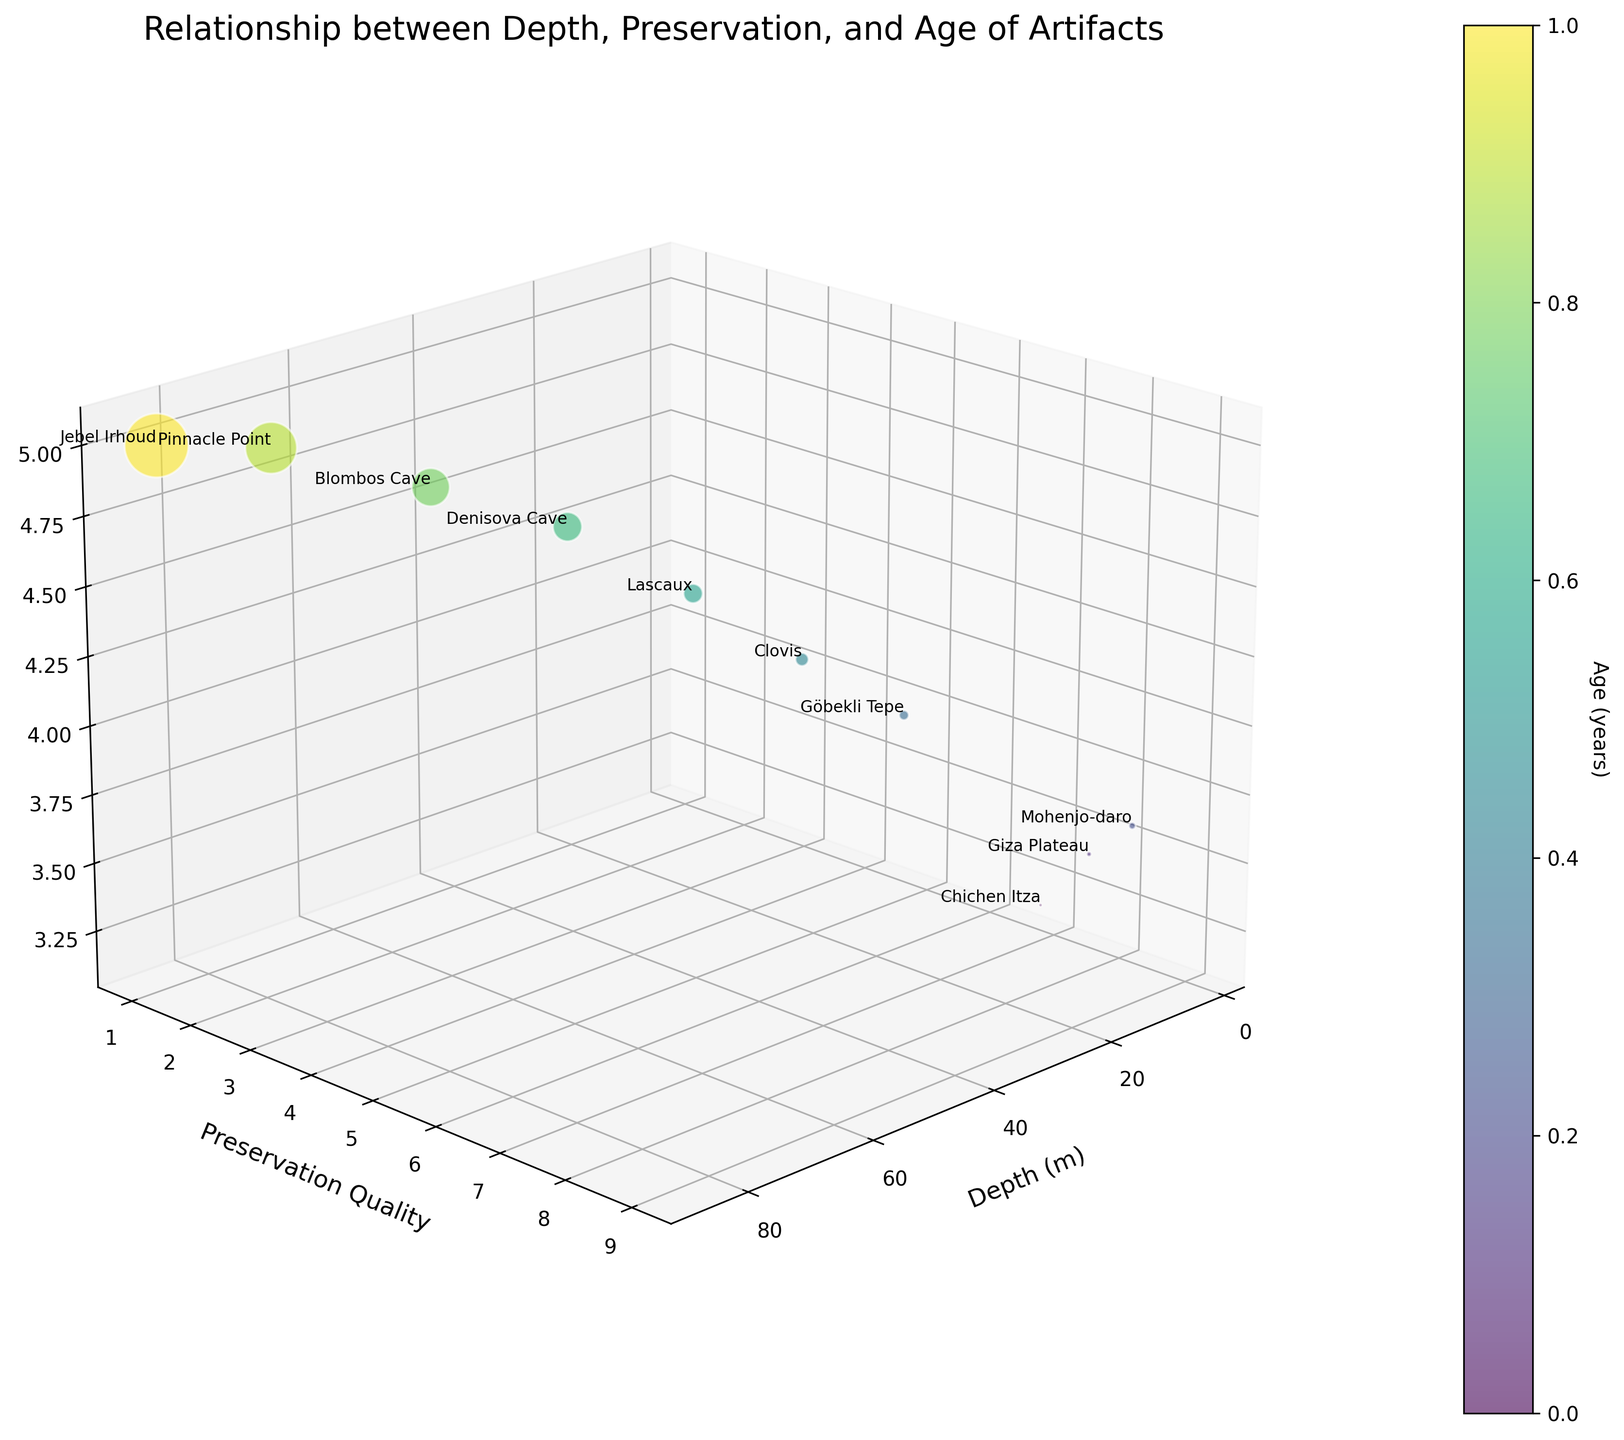How many data points are shown in the plot? Count each unique bubble represented in the 3D space.
Answer: 10 What axis shows the depth measurement? Identify the axis labeled "Depth (m)," which clarifies the axis associated with depth in meters.
Answer: The x-axis Describe the color gradient used in the plot. Observe the range and color scheme applied to the bubbles and look at the color bar legend for reference. The color gradient usually changes to show varying scales.
Answer: It transitions from blue to green to yellow to red representing increasing depth Which site has the oldest artifacts based on estimated age? Check the bubble positioned at the highest Log10(Estimated Age) value and then check the text annotation.
Answer: Jebel Irhoud Which two sites have the same preservation quality rating but are at different depths? Find bubbles that share the same Preservation Quality value on the y-axis, then compare their corresponding Depth (m) values on the x-axis.
Answer: Pinnacle Point and Jebel Irhoud On average, is the preservation quality higher for artifacts found at shallower depths compared to deeper depths? Compare the Preservation Quality values of data points found at shallower depths (closer to the x-axis origin) to those at greater depths. Higher ratings should mostly appear near lower depth values for the statement to be true.
Answer: Yes Compare the preservation qualities of artifacts found in Giza Plateau and Blombos Cave. Which one has better-preserved artifacts? Identify the y-values (Preservation Quality rating) corresponding to Giza Plateau and Blombos Cave and compare them.
Answer: Giza Plateau (8 vs 2) Is there a general trend observed between depth and preservation quality? Assess the overall distribution of bubbles along the x-axis (Depth) and y-axis (Preservation Quality) to check for any evident pattern, such as whether deeper artifacts are generally associated with higher or lower preservation quality ratings.
Answer: Yes, preservation quality decreases with depth Which artifact type is found at the greatest depth? Observe the bubbles along the x-axis, identify the furthest point to the right, and check the text annotation for the artifact type.
Answer: Homo Sapiens Fossils 